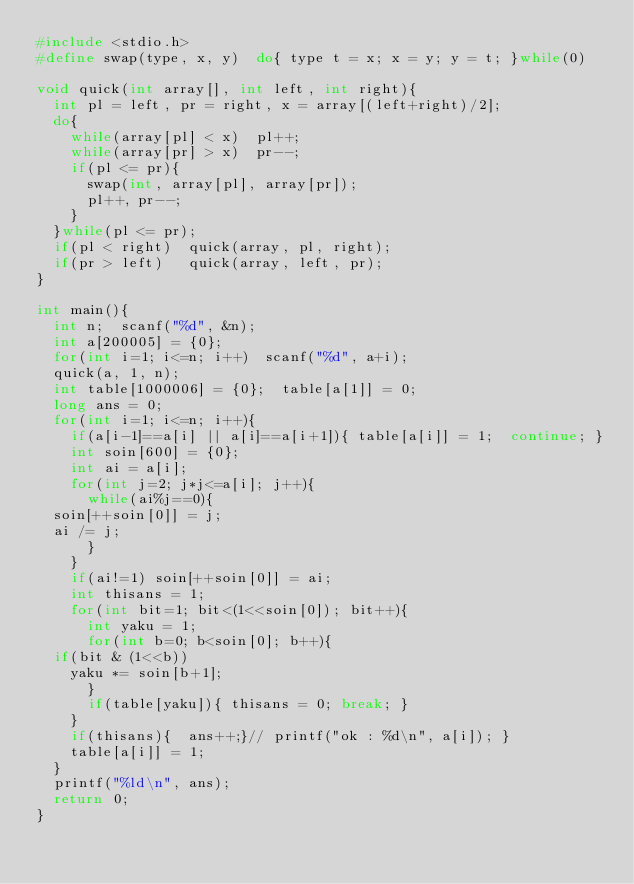Convert code to text. <code><loc_0><loc_0><loc_500><loc_500><_C_>#include <stdio.h>
#define swap(type, x, y)  do{ type t = x; x = y; y = t; }while(0)

void quick(int array[], int left, int right){
  int pl = left, pr = right, x = array[(left+right)/2];
  do{
    while(array[pl] < x)  pl++;
    while(array[pr] > x)  pr--;
    if(pl <= pr){
      swap(int, array[pl], array[pr]);
      pl++, pr--;
    }
  }while(pl <= pr);
  if(pl < right)  quick(array, pl, right);
  if(pr > left)   quick(array, left, pr);
}

int main(){
  int n;  scanf("%d", &n);
  int a[200005] = {0};
  for(int i=1; i<=n; i++)  scanf("%d", a+i);
  quick(a, 1, n);
  int table[1000006] = {0};  table[a[1]] = 0;
  long ans = 0;
  for(int i=1; i<=n; i++){
    if(a[i-1]==a[i] || a[i]==a[i+1]){ table[a[i]] = 1;  continue; }
    int soin[600] = {0};
    int ai = a[i];
    for(int j=2; j*j<=a[i]; j++){
      while(ai%j==0){
	soin[++soin[0]] = j;
	ai /= j;
      }
    }
    if(ai!=1) soin[++soin[0]] = ai;
    int thisans = 1;
    for(int bit=1; bit<(1<<soin[0]); bit++){
      int yaku = 1;
      for(int b=0; b<soin[0]; b++){
	if(bit & (1<<b))
	  yaku *= soin[b+1];
      }
      if(table[yaku]){ thisans = 0; break; }
    }
    if(thisans){  ans++;}// printf("ok : %d\n", a[i]); }
    table[a[i]] = 1;
  }
  printf("%ld\n", ans);
  return 0;
}
</code> 